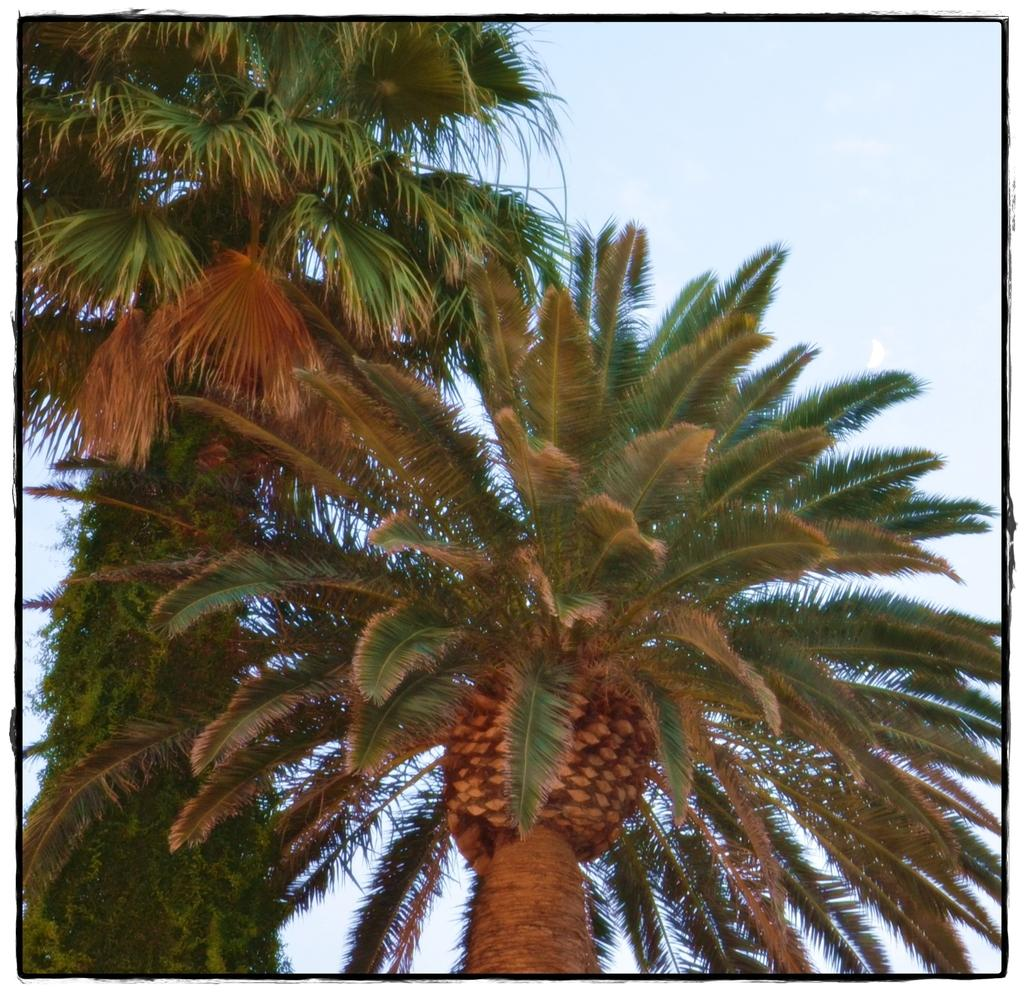What type of vegetation can be seen in the image? There are trees in the image. What part of the natural environment is visible in the background of the image? The sky is visible in the background of the image. What type of can is visible in the image? There is no can present in the image; it only features trees and the sky. What type of sea can be seen in the image? There is no sea present in the image; it only features trees and the sky. 